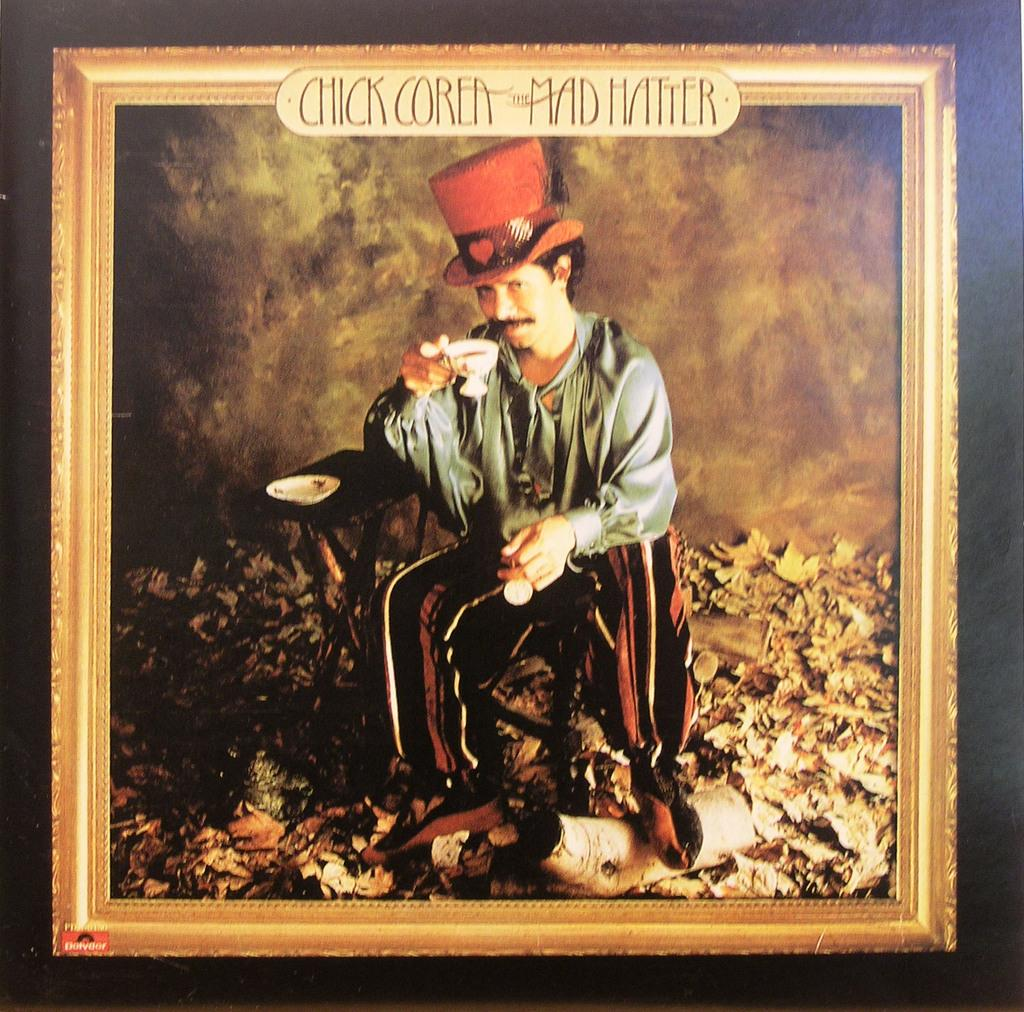<image>
Provide a brief description of the given image. A photograph is titled "Chick Corea the Mad Hatter" and features a man wearing a tall hat. 